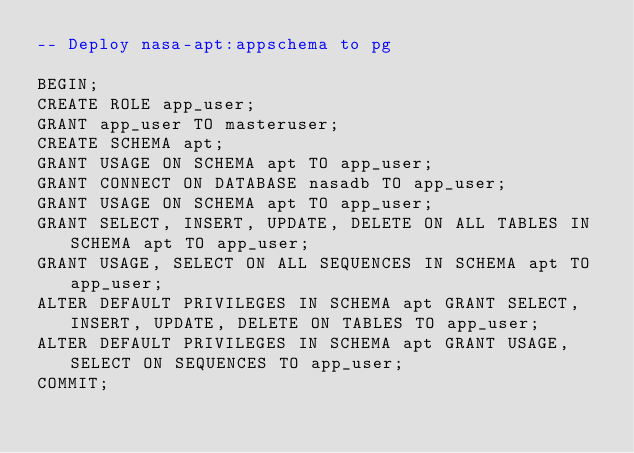<code> <loc_0><loc_0><loc_500><loc_500><_SQL_>-- Deploy nasa-apt:appschema to pg

BEGIN;
CREATE ROLE app_user;
GRANT app_user TO masteruser;
CREATE SCHEMA apt;
GRANT USAGE ON SCHEMA apt TO app_user;
GRANT CONNECT ON DATABASE nasadb TO app_user;
GRANT USAGE ON SCHEMA apt TO app_user;
GRANT SELECT, INSERT, UPDATE, DELETE ON ALL TABLES IN SCHEMA apt TO app_user;
GRANT USAGE, SELECT ON ALL SEQUENCES IN SCHEMA apt TO app_user;
ALTER DEFAULT PRIVILEGES IN SCHEMA apt GRANT SELECT, INSERT, UPDATE, DELETE ON TABLES TO app_user;
ALTER DEFAULT PRIVILEGES IN SCHEMA apt GRANT USAGE, SELECT ON SEQUENCES TO app_user;
COMMIT;
</code> 